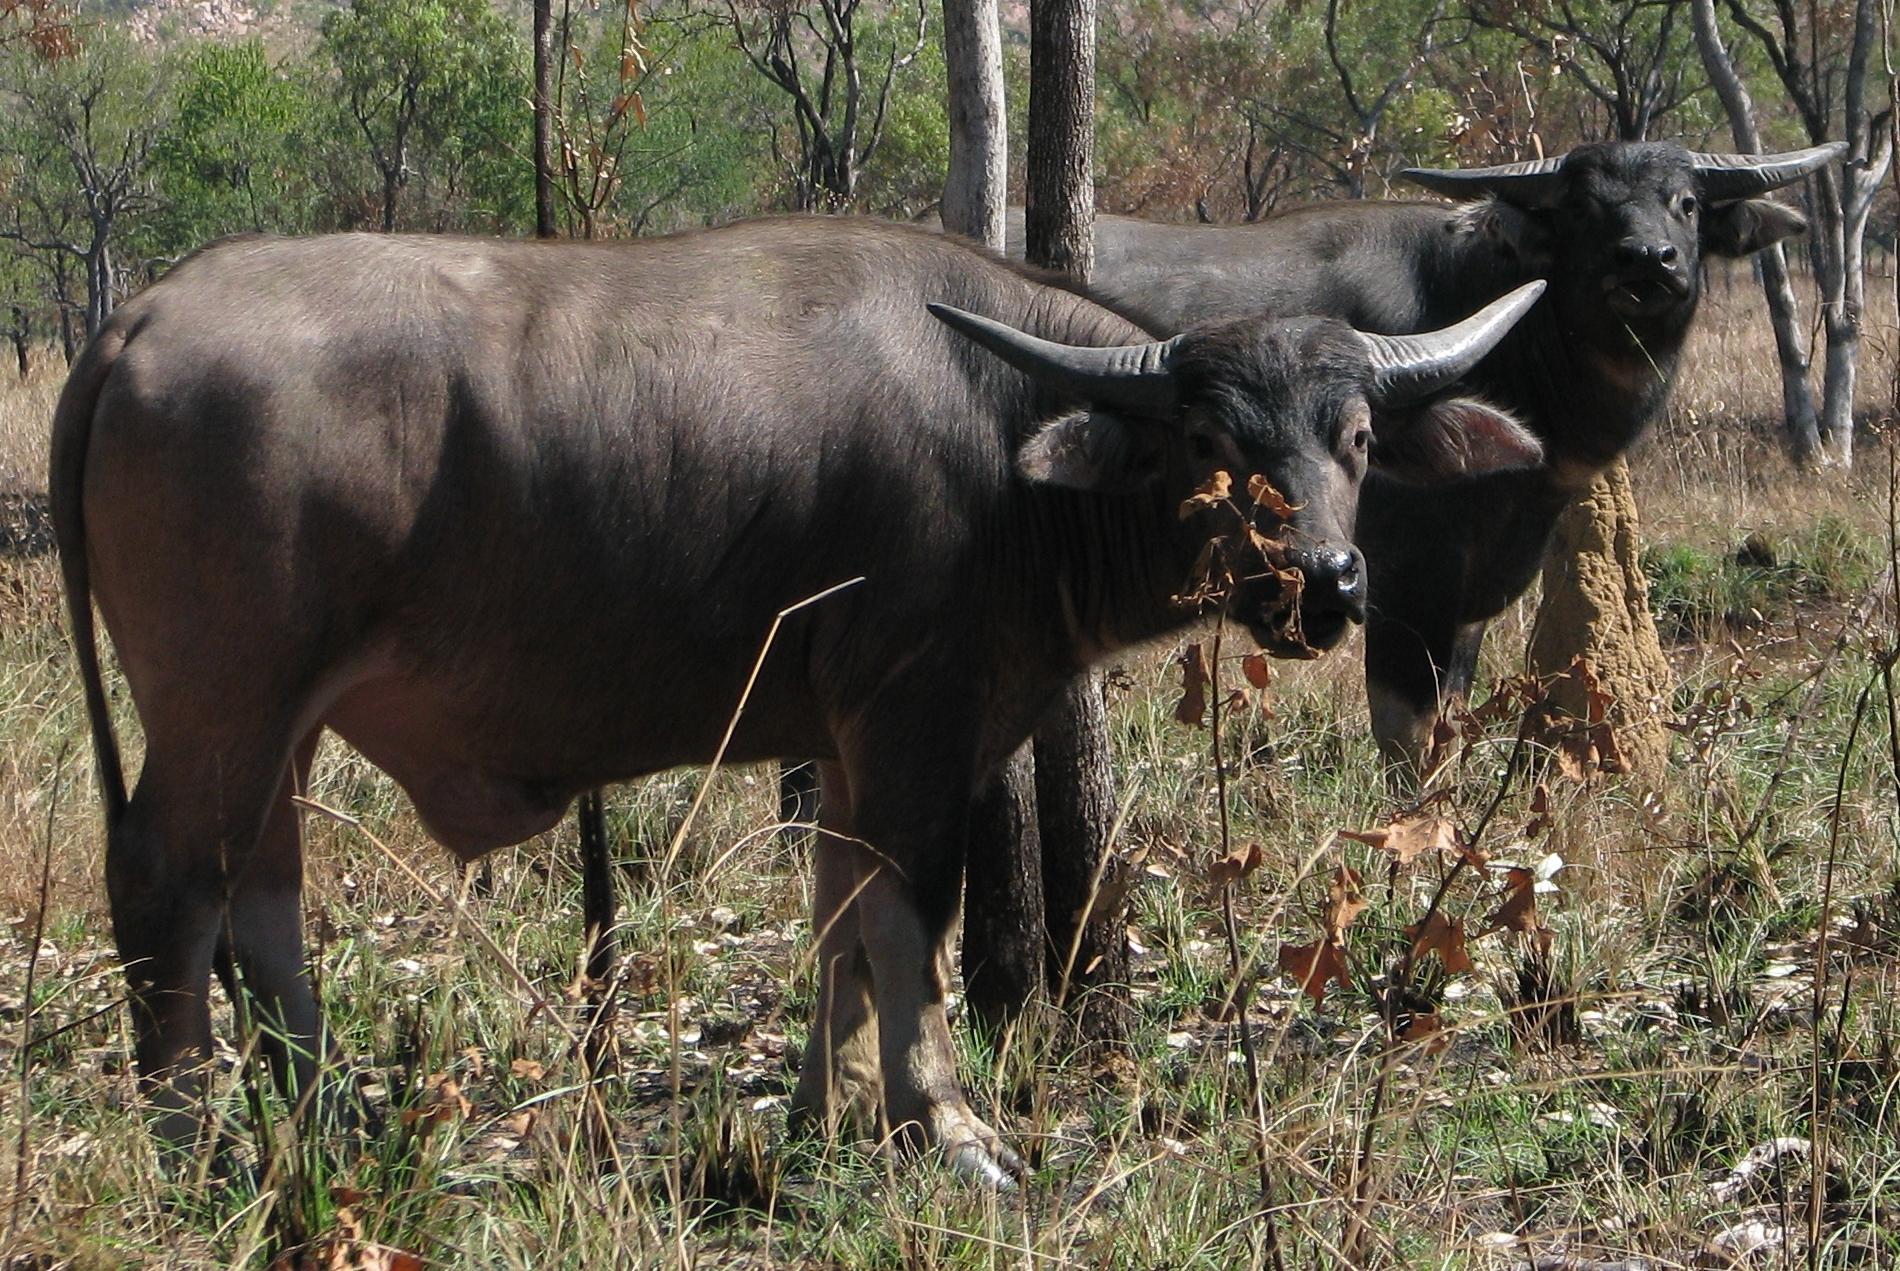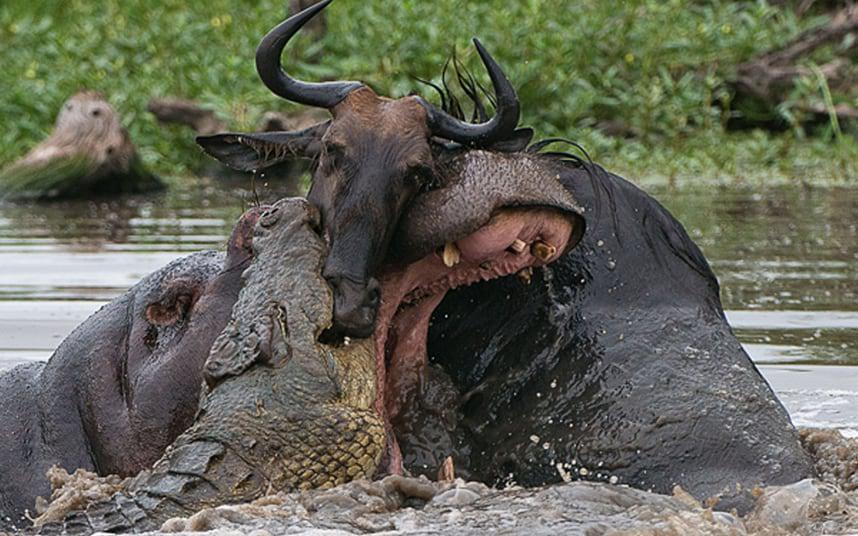The first image is the image on the left, the second image is the image on the right. Given the left and right images, does the statement "In one of the images, the wildebeest are chasing the lion." hold true? Answer yes or no. No. 